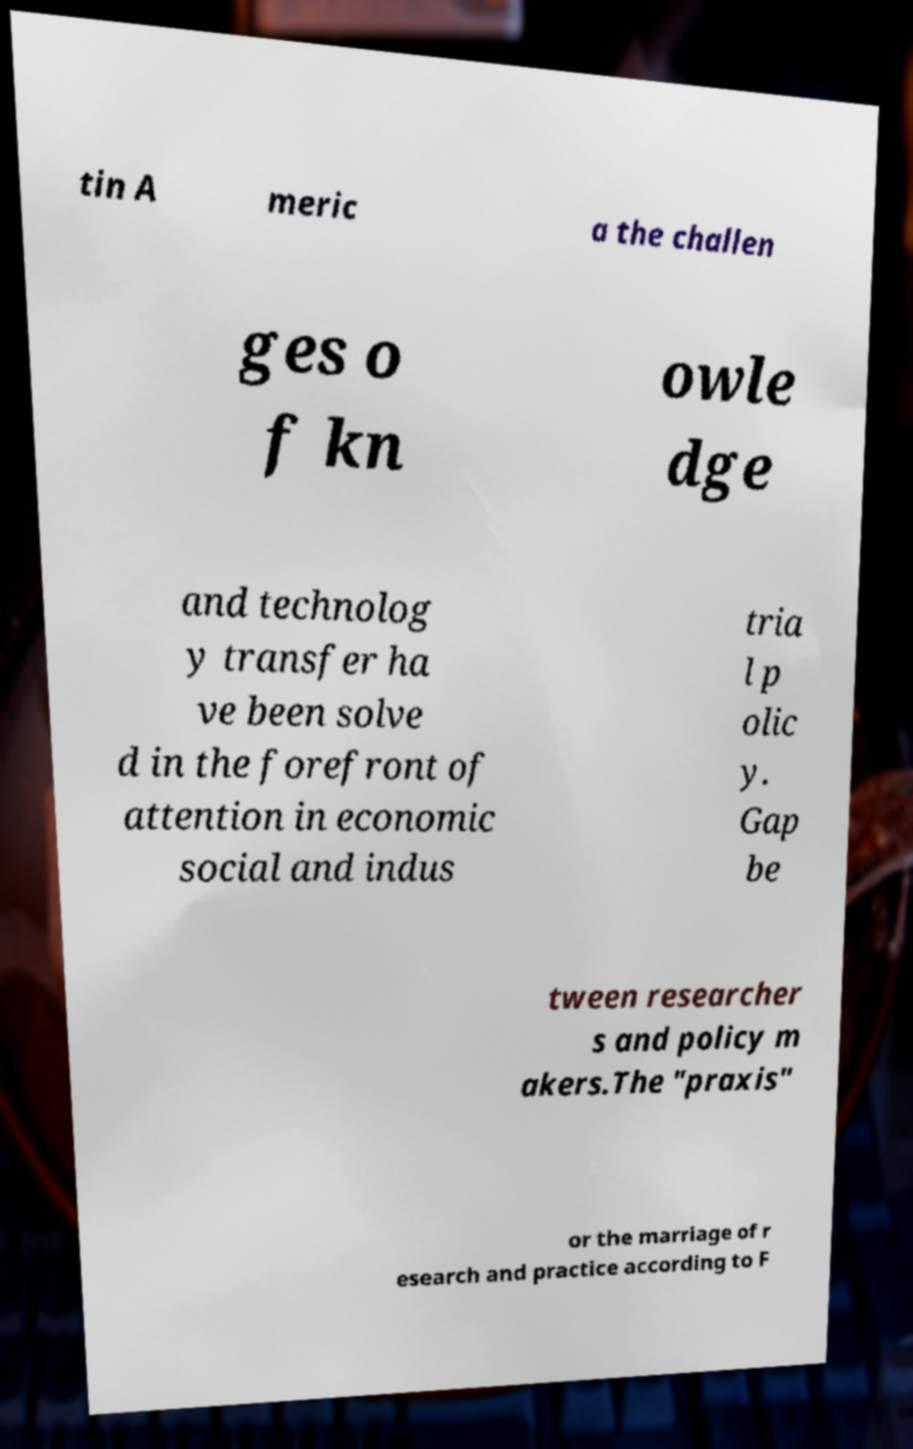What messages or text are displayed in this image? I need them in a readable, typed format. tin A meric a the challen ges o f kn owle dge and technolog y transfer ha ve been solve d in the forefront of attention in economic social and indus tria l p olic y. Gap be tween researcher s and policy m akers.The "praxis" or the marriage of r esearch and practice according to F 